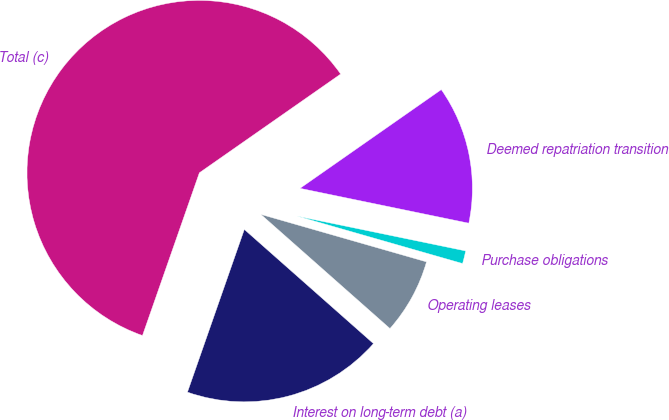Convert chart. <chart><loc_0><loc_0><loc_500><loc_500><pie_chart><fcel>Interest on long-term debt (a)<fcel>Operating leases<fcel>Purchase obligations<fcel>Deemed repatriation transition<fcel>Total (c)<nl><fcel>18.83%<fcel>7.08%<fcel>1.2%<fcel>12.95%<fcel>59.94%<nl></chart> 